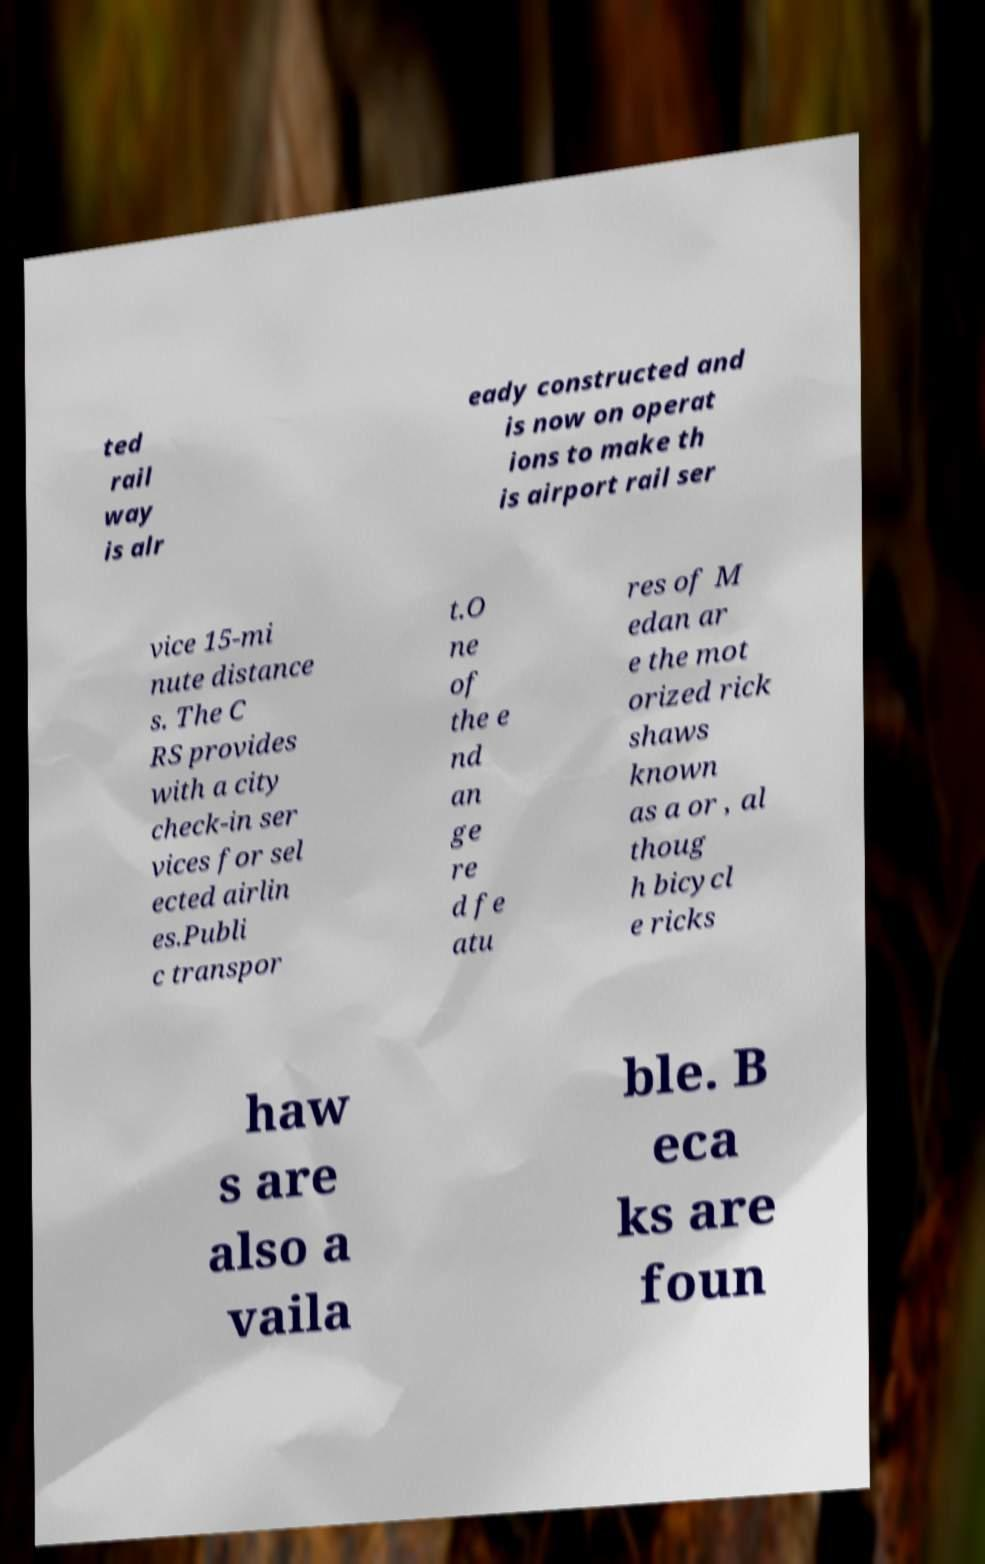Can you read and provide the text displayed in the image?This photo seems to have some interesting text. Can you extract and type it out for me? ted rail way is alr eady constructed and is now on operat ions to make th is airport rail ser vice 15-mi nute distance s. The C RS provides with a city check-in ser vices for sel ected airlin es.Publi c transpor t.O ne of the e nd an ge re d fe atu res of M edan ar e the mot orized rick shaws known as a or , al thoug h bicycl e ricks haw s are also a vaila ble. B eca ks are foun 